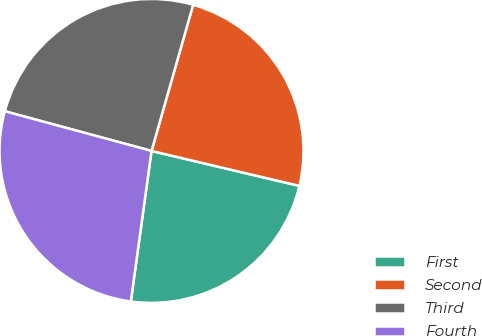Convert chart. <chart><loc_0><loc_0><loc_500><loc_500><pie_chart><fcel>First<fcel>Second<fcel>Third<fcel>Fourth<nl><fcel>23.48%<fcel>24.28%<fcel>25.21%<fcel>27.03%<nl></chart> 